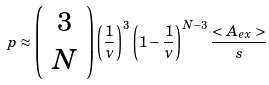Convert formula to latex. <formula><loc_0><loc_0><loc_500><loc_500>p \approx \left ( \begin{array} { c } 3 \\ N \end{array} \right ) \left ( \frac { 1 } { \nu } \right ) ^ { 3 } \left ( 1 - \frac { 1 } { \nu } \right ) ^ { N - 3 } \frac { < A _ { e x } > } { s }</formula> 